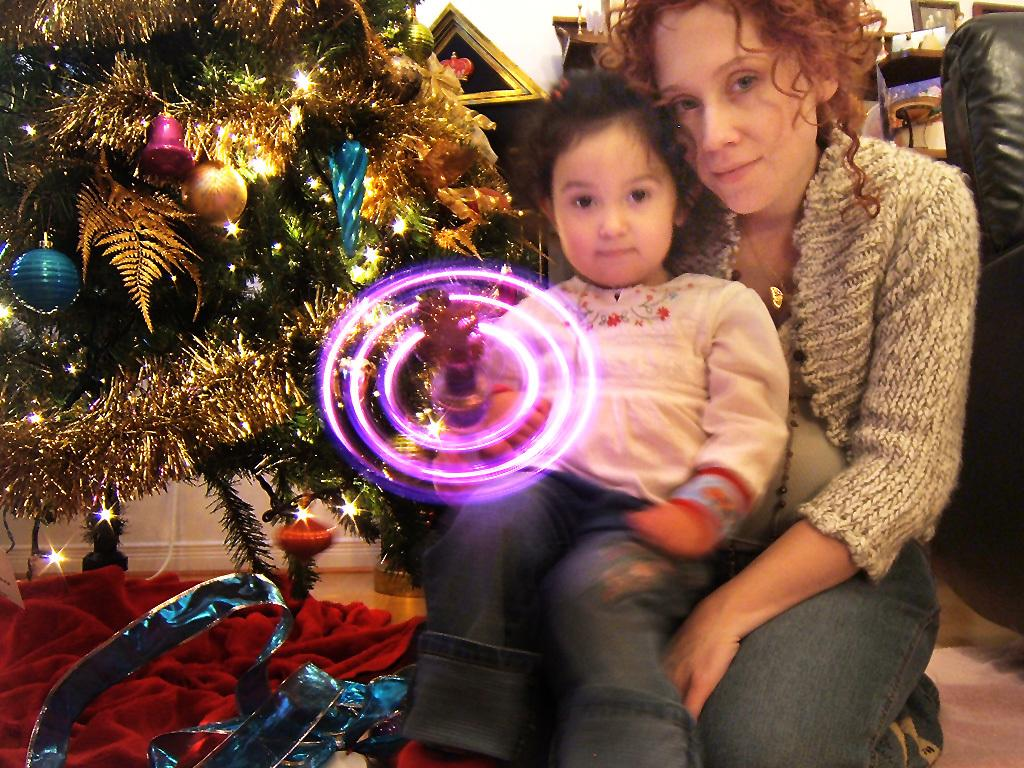Who is the main subject in the image? There is a woman in the image. What is the woman holding? The woman is holding a baby. What can be seen on the left side of the image? There is a Christmas tree on the left side of the image. What is behind the woman in the image? There is a sofa behind the woman. What other objects are visible in the image? There are other objects visible in the image, but their specific details are not mentioned in the provided facts. What type of carriage can be seen in the image? There is no carriage present in the image. How many cows are visible in the image? There are no cows visible in the image. 